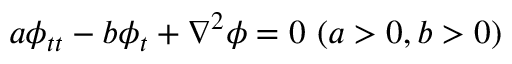Convert formula to latex. <formula><loc_0><loc_0><loc_500><loc_500>a \phi _ { t t } - b \phi _ { t } + \nabla ^ { 2 } \phi = 0 \ ( a > 0 , b > 0 )</formula> 